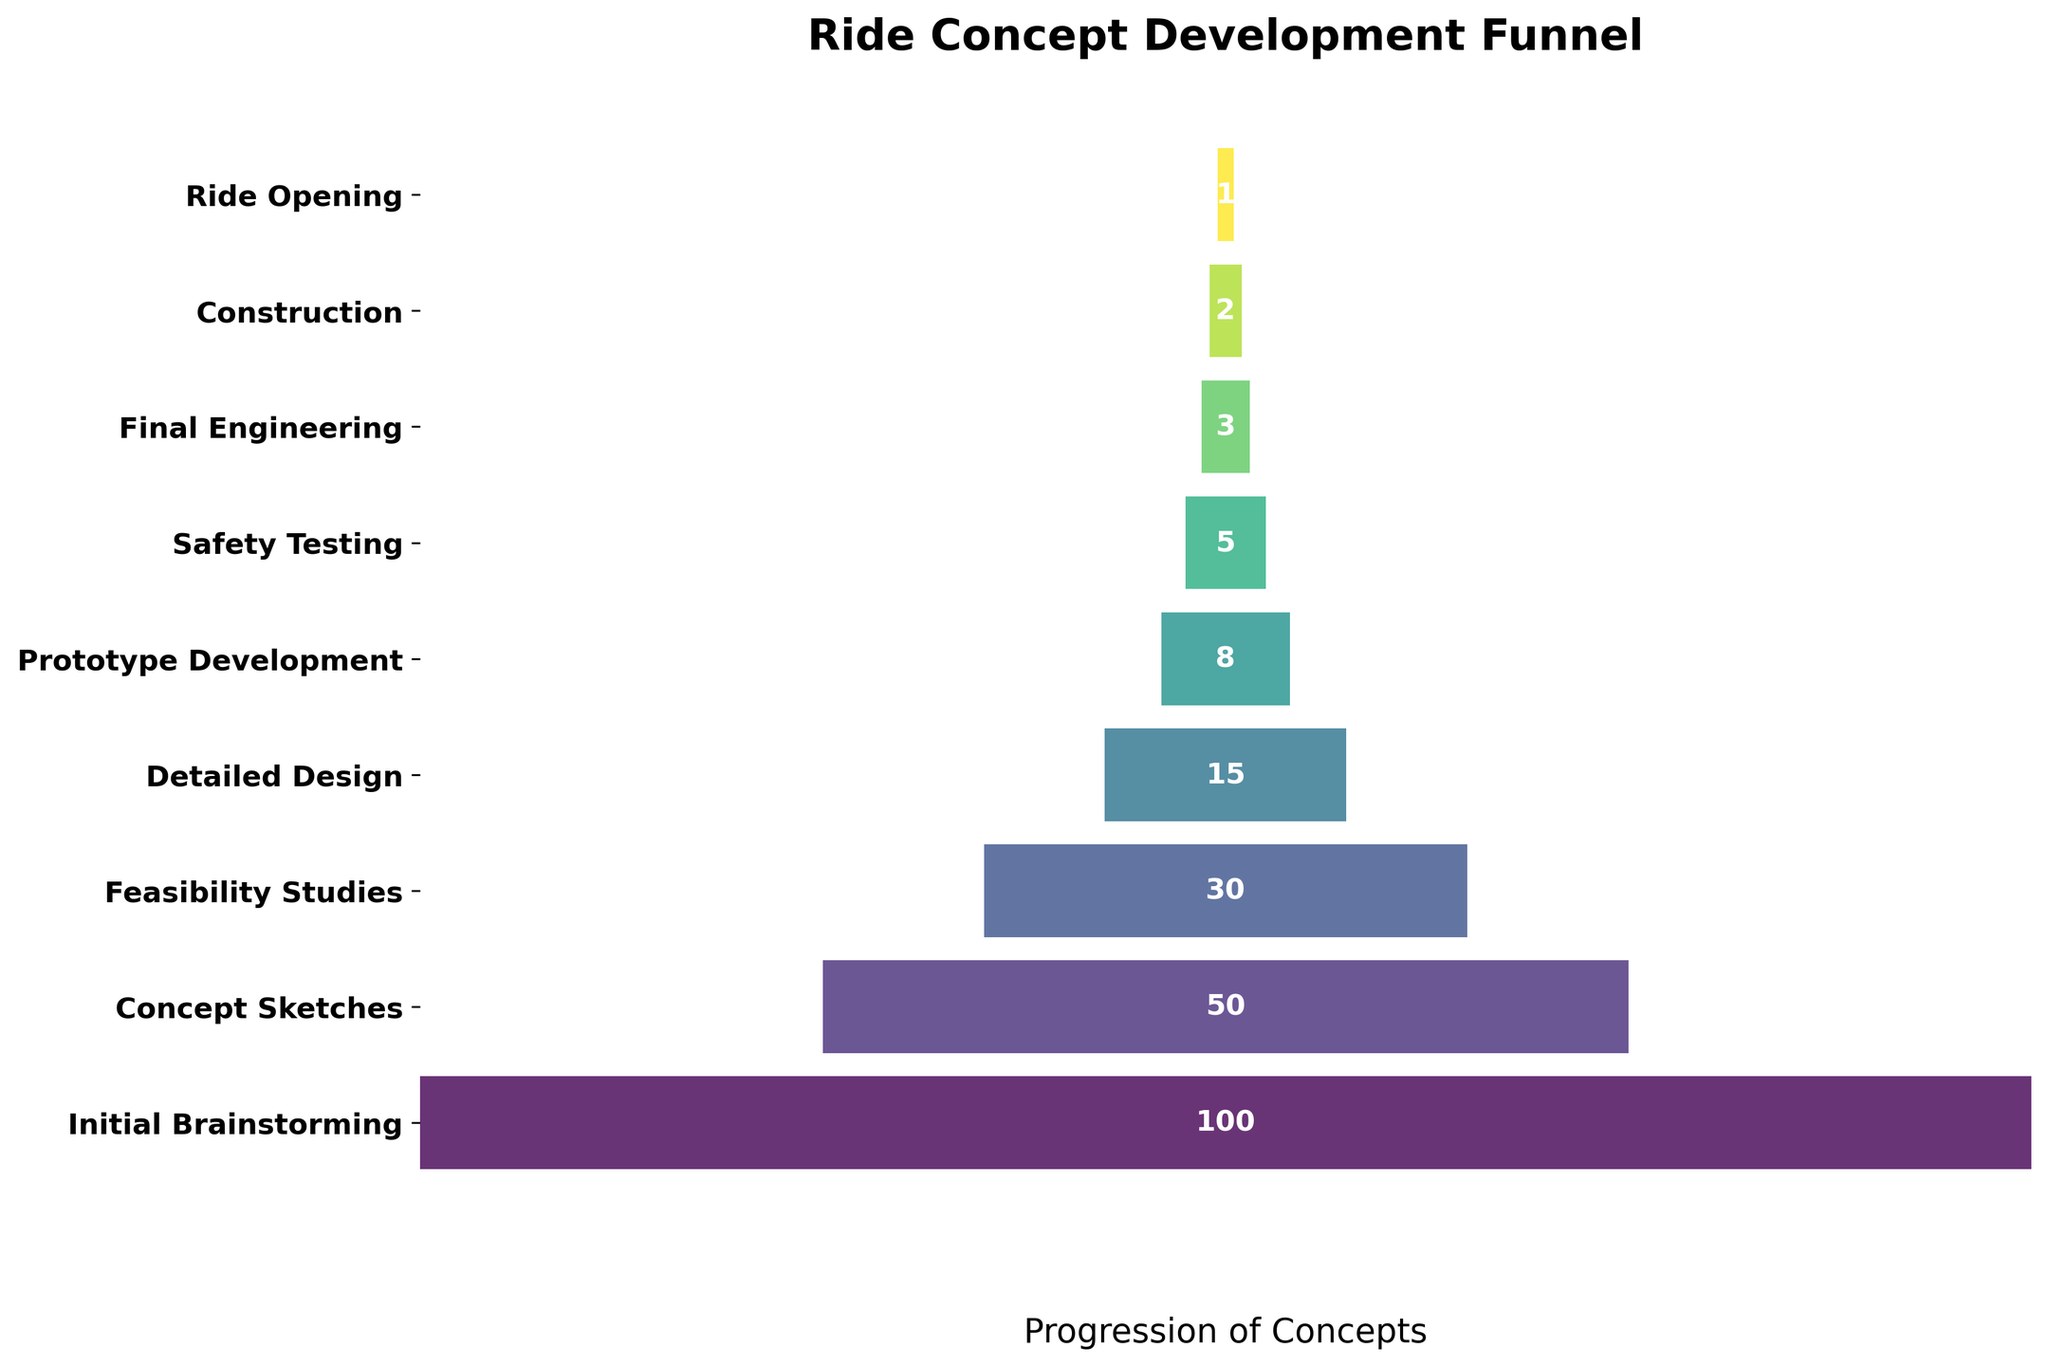How many stages are shown in the funnel? The stages are represented by bars along the y-axis, and each label corresponds to a stage in the development funnel. By counting the labels, we find there are nine stages: Initial Brainstorming, Concept Sketches, Feasibility Studies, Detailed Design, Prototype Development, Safety Testing, Final Engineering, Construction, and Ride Opening.
Answer: Nine Which stage has the highest number of concepts? The stage with the largest bar in the funnel chart is at the top, labeled "Initial Brainstorming," indicating the highest number of concepts.
Answer: Initial Brainstorming What is the difference in the number of concepts between "Concept Sketches" and "Feasibility Studies"? "Concept Sketches" has 50 concepts, and "Feasibility Studies" has 30 concepts. The difference is calculated by subtracting the number of concepts in "Feasibility Studies" from that in "Concept Sketches" (50 - 30 = 20).
Answer: 20 How many stages see more than half of the concepts drop off compared to their previous stage? Comparing each stage to the previous, we notice significant drops. The drops are as follows: Brainstorming to Sketches (100 to 50 - 50%), Sketches to Feasibility (50 to 30), Feasibility to Design (30 to 15 - 50%), Design to Prototype (15 to 8), Prototype to Testing (8 to 5), Testing to Engineering (5 to 3), Engineering to Construction (3 to 2), and Construction to Opening (2 to 1 - 50%). Three stages (Brainstorming to Sketches, Feasibility to Design, and Construction to Opening) have more than a 50% drop.
Answer: Three Which stage has the fewest concepts before reaching the final stage? Moving sequentially through the funnel, we observe "Construction" has 2 concepts, making it the stage just before the final "Ride Opening" stage with only 1 concept.
Answer: Construction Among the stages "Detailed Design" and "Prototype Development," which one shows a greater reduction in concepts from its preceding stage? Detailed Design reduced from Feasibility Studies by 15 (30 to 15), while Prototype Development reduced from Detailed Design by 7 (15 to 8). Therefore, Detailed Design shows a greater reduction in concepts.
Answer: Detailed Design What fraction of the initial concepts reach the "Final Engineering" stage? The initial number of concepts is 100, and 3 concepts reach "Final Engineering." The fraction is calculated as 3 out of 100, which simplifies to 3/100 or 0.03.
Answer: 0.03 What percentage of concepts initially brainstormed go on to the "Ride Opening"? The initial number of concepts is 100, and 1 concept reaches "Ride Opening." The percentage is calculated as (1/100) * 100 = 1%.
Answer: 1% Which stages have exactly 5 or fewer concepts remaining? By looking at the numbers within the funnel chart, the stages with 5 or fewer concepts are "Safety Testing" (5), "Final Engineering" (3), "Construction" (2), and "Ride Opening" (1).
Answer: Safety Testing, Final Engineering, Construction, Ride Opening Is there a stage where exactly half of the concepts remain from the previous stage? To find this, we check each sequential drop: Initial Brainstorming to Concept Sketches (100 to 50) is exactly half.
Answer: Concept Sketches 